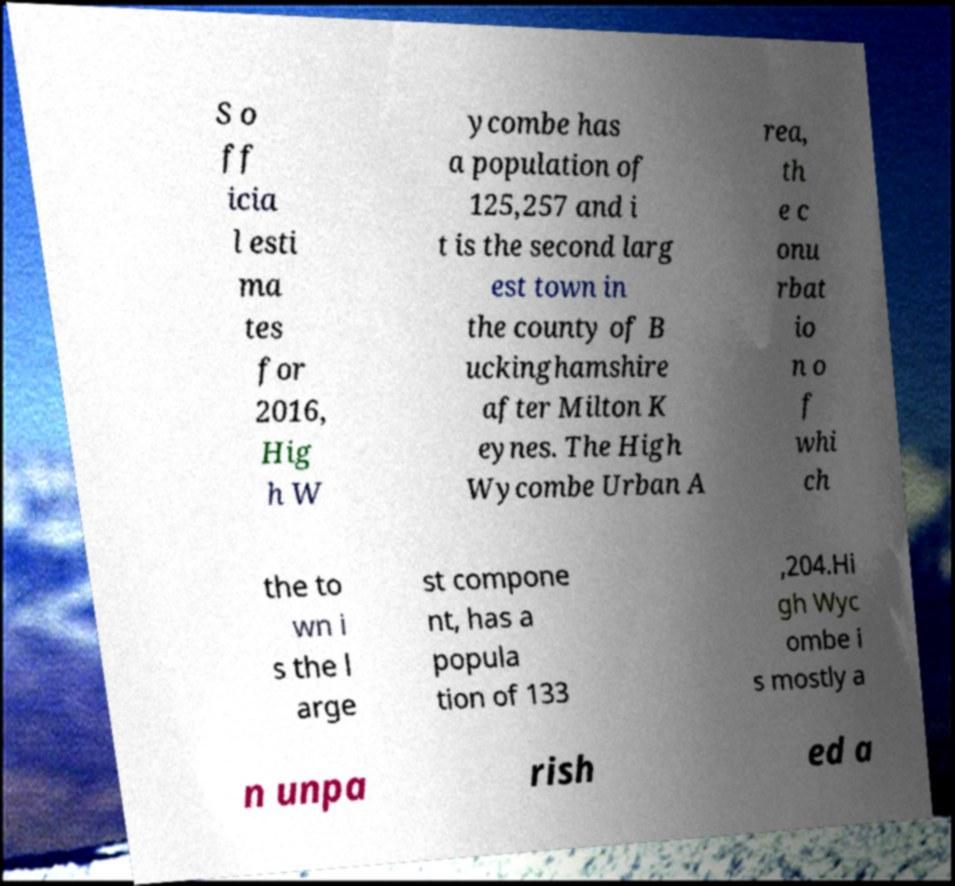What messages or text are displayed in this image? I need them in a readable, typed format. S o ff icia l esti ma tes for 2016, Hig h W ycombe has a population of 125,257 and i t is the second larg est town in the county of B uckinghamshire after Milton K eynes. The High Wycombe Urban A rea, th e c onu rbat io n o f whi ch the to wn i s the l arge st compone nt, has a popula tion of 133 ,204.Hi gh Wyc ombe i s mostly a n unpa rish ed a 